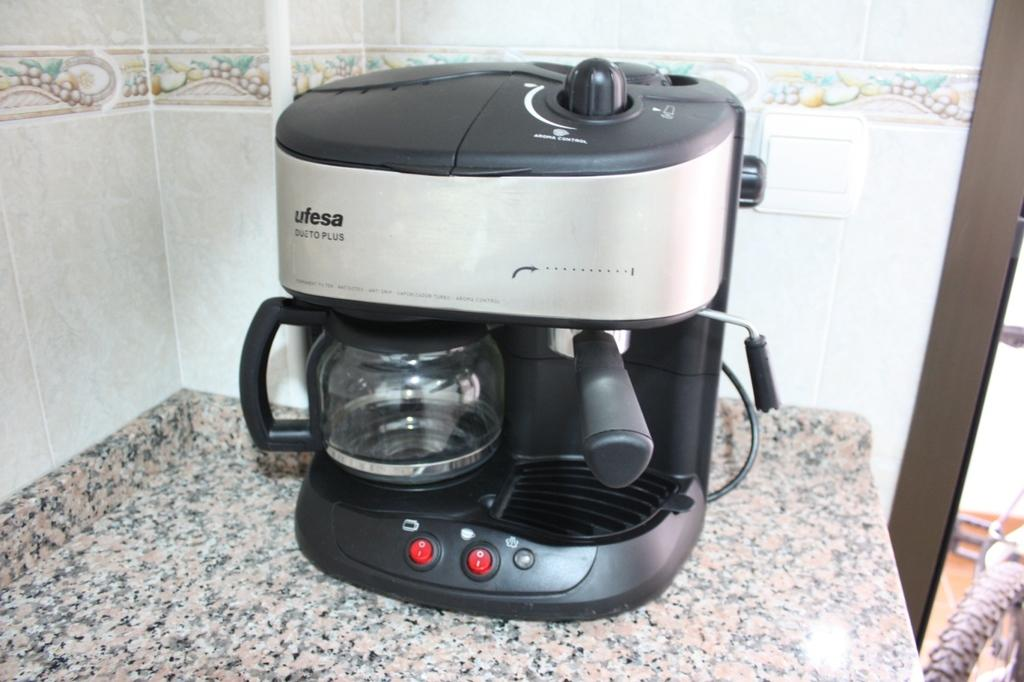<image>
Give a short and clear explanation of the subsequent image. A coffee maker that says ufesa in black letters. 